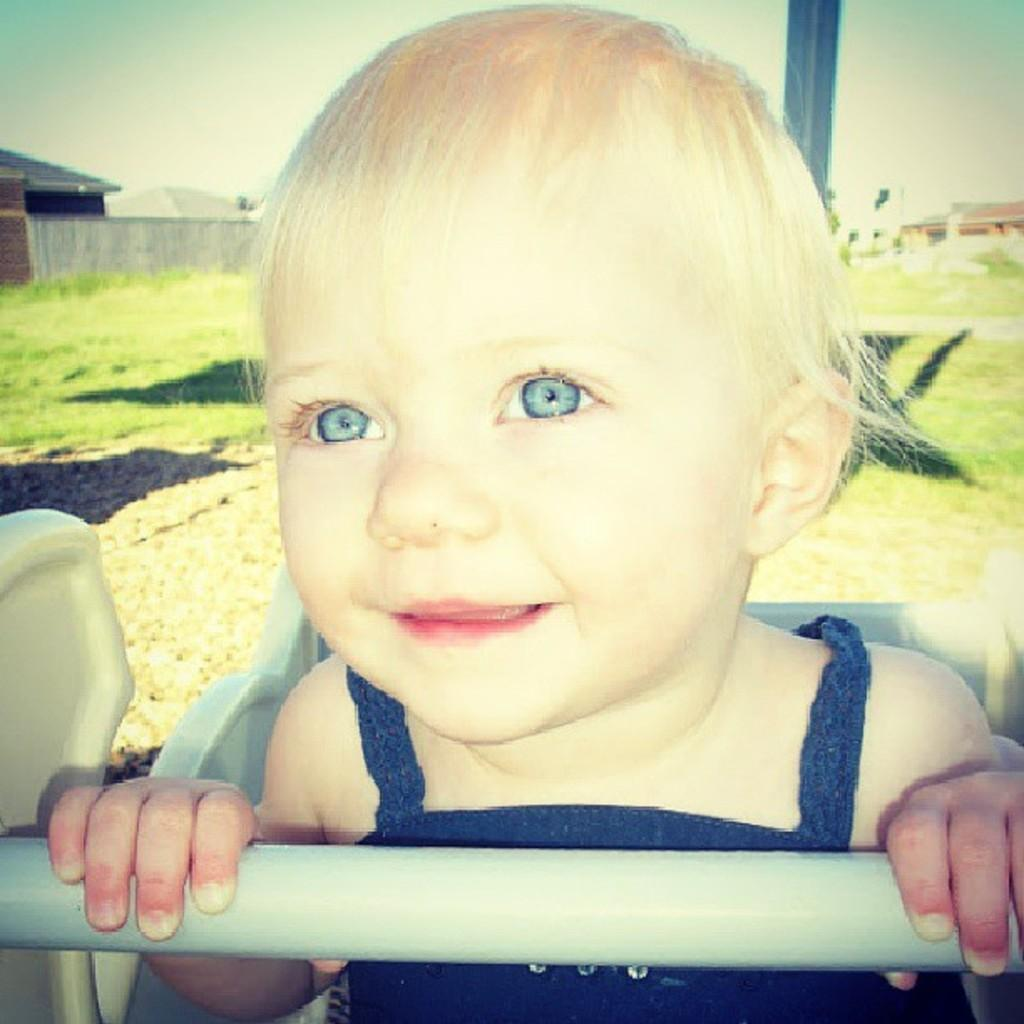What is the main subject of the image? The main subject of the image is a kid sitting on a chair. What can be seen in the background of the image? There is a pole on the grassland and buildings visible in the background. What is visible at the top of the image? The sky is visible at the top of the image. How many frogs are jumping around the kid in the image? There are no frogs present in the image. What type of duck can be seen swimming in the background? There is no duck present in the image. 